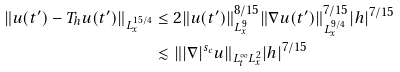Convert formula to latex. <formula><loc_0><loc_0><loc_500><loc_500>\| u ( t ^ { \prime } ) - T _ { h } u ( t ^ { \prime } ) \| _ { L _ { x } ^ { 1 5 / 4 } } & \leq 2 \| u ( t ^ { \prime } ) \| _ { L _ { x } ^ { 9 } } ^ { 8 / 1 5 } \| \nabla u ( t ^ { \prime } ) \| _ { L _ { x } ^ { 9 / 4 } } ^ { 7 / 1 5 } | h | ^ { 7 / 1 5 } \\ & \lesssim \| | \nabla | ^ { s _ { c } } u \| _ { L _ { t } ^ { \infty } L _ { x } ^ { 2 } } | h | ^ { 7 / 1 5 }</formula> 